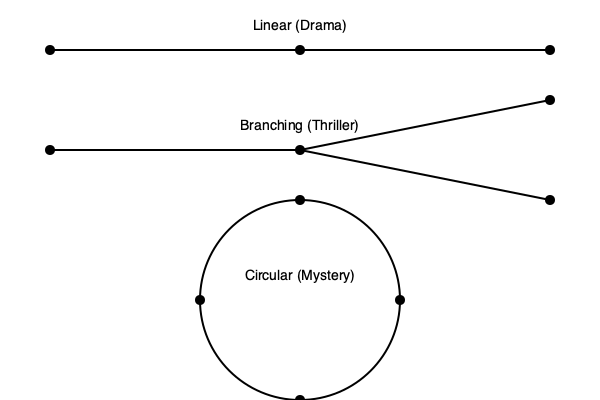Analyze the narrative structures depicted in the diagram and explain how they reflect the storytelling approaches in different screenplay genres. Which structure would be most effective for a complex, multi-layered screenplay that explores parallel timelines and alternate realities? To answer this question, let's analyze each narrative structure and its corresponding genre:

1. Linear Structure (Drama):
   - Represents a straightforward, chronological narrative.
   - Events unfold sequentially from beginning to end.
   - Typically used in character-driven dramas where emotional arcs are paramount.
   - Allows for focused character development and thematic exploration.

2. Branching Structure (Thriller):
   - Shows a narrative that splits into multiple paths.
   - Represents decision points or plot twists that lead to different outcomes.
   - Common in thrillers where suspense is built through unpredictable story directions.
   - Allows for exploration of cause-and-effect relationships and "what-if" scenarios.

3. Circular Structure (Mystery):
   - Depicts a narrative that ends where it begins.
   - Often used in mysteries where the resolution ties back to the initial setup.
   - Encourages non-linear storytelling and revelation of information.
   - Suitable for stories with themes of repetition, cycles, or inevitable outcomes.

For a complex, multi-layered screenplay exploring parallel timelines and alternate realities, the most effective structure would be a combination of branching and circular elements. This hybrid approach would allow for:

- Multiple narrative paths (branching) to represent different timelines or realities.
- Interconnectedness between storylines (circular) to show how alternate realities influence each other.
- Non-linear storytelling to jump between timelines and realities.
- Exploration of cause-and-effect across different realities.
- Potential for a circular overall structure, where the end of the story links back to the beginning in a meaningful way.

This complex structure would enable the screenplay to effectively convey the intricacies of parallel timelines and alternate realities while maintaining a cohesive narrative that engages the audience through its multi-layered approach.
Answer: A hybrid of branching and circular structures 